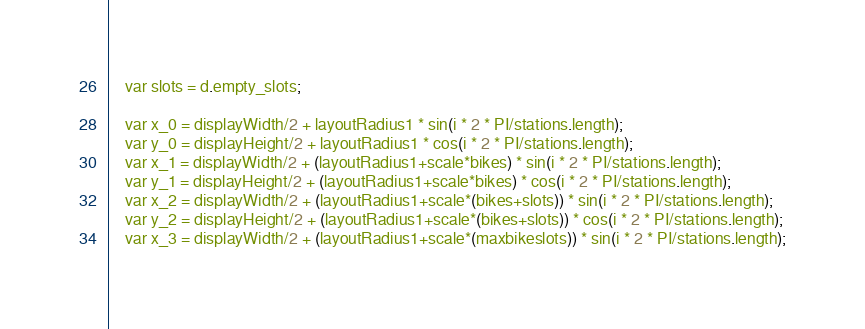<code> <loc_0><loc_0><loc_500><loc_500><_JavaScript_>    var slots = d.empty_slots;

    var x_0 = displayWidth/2 + layoutRadius1 * sin(i * 2 * PI/stations.length);
    var y_0 = displayHeight/2 + layoutRadius1 * cos(i * 2 * PI/stations.length);
    var x_1 = displayWidth/2 + (layoutRadius1+scale*bikes) * sin(i * 2 * PI/stations.length);
    var y_1 = displayHeight/2 + (layoutRadius1+scale*bikes) * cos(i * 2 * PI/stations.length);
    var x_2 = displayWidth/2 + (layoutRadius1+scale*(bikes+slots)) * sin(i * 2 * PI/stations.length);
    var y_2 = displayHeight/2 + (layoutRadius1+scale*(bikes+slots)) * cos(i * 2 * PI/stations.length);
    var x_3 = displayWidth/2 + (layoutRadius1+scale*(maxbikeslots)) * sin(i * 2 * PI/stations.length);</code> 